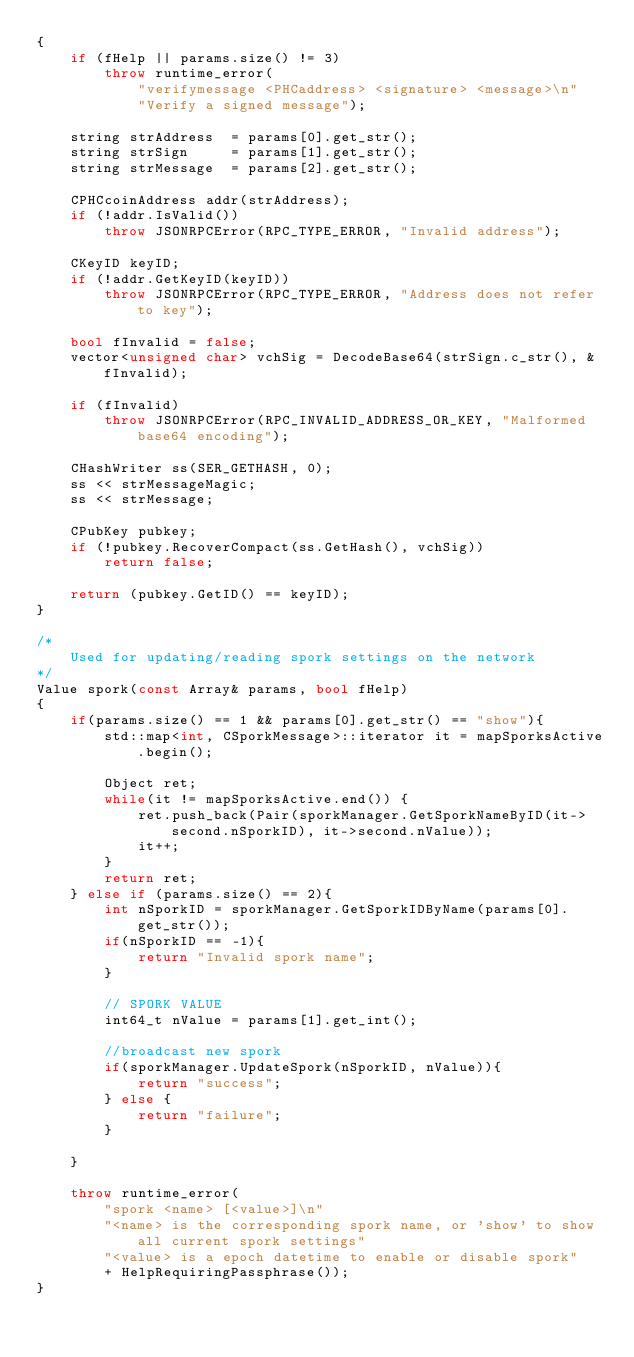<code> <loc_0><loc_0><loc_500><loc_500><_C++_>{
    if (fHelp || params.size() != 3)
        throw runtime_error(
            "verifymessage <PHCaddress> <signature> <message>\n"
            "Verify a signed message");

    string strAddress  = params[0].get_str();
    string strSign     = params[1].get_str();
    string strMessage  = params[2].get_str();

    CPHCcoinAddress addr(strAddress);
    if (!addr.IsValid())
        throw JSONRPCError(RPC_TYPE_ERROR, "Invalid address");

    CKeyID keyID;
    if (!addr.GetKeyID(keyID))
        throw JSONRPCError(RPC_TYPE_ERROR, "Address does not refer to key");

    bool fInvalid = false;
    vector<unsigned char> vchSig = DecodeBase64(strSign.c_str(), &fInvalid);

    if (fInvalid)
        throw JSONRPCError(RPC_INVALID_ADDRESS_OR_KEY, "Malformed base64 encoding");

    CHashWriter ss(SER_GETHASH, 0);
    ss << strMessageMagic;
    ss << strMessage;

    CPubKey pubkey;
    if (!pubkey.RecoverCompact(ss.GetHash(), vchSig))
        return false;

    return (pubkey.GetID() == keyID);
}

/*
    Used for updating/reading spork settings on the network
*/
Value spork(const Array& params, bool fHelp)
{
    if(params.size() == 1 && params[0].get_str() == "show"){
        std::map<int, CSporkMessage>::iterator it = mapSporksActive.begin();

        Object ret;
        while(it != mapSporksActive.end()) {
            ret.push_back(Pair(sporkManager.GetSporkNameByID(it->second.nSporkID), it->second.nValue));
            it++;
        }
        return ret;
    } else if (params.size() == 2){
        int nSporkID = sporkManager.GetSporkIDByName(params[0].get_str());
        if(nSporkID == -1){
            return "Invalid spork name";
        }

        // SPORK VALUE
        int64_t nValue = params[1].get_int();

        //broadcast new spork
        if(sporkManager.UpdateSpork(nSporkID, nValue)){
            return "success";
        } else {
            return "failure";
        }

    }

    throw runtime_error(
        "spork <name> [<value>]\n"
        "<name> is the corresponding spork name, or 'show' to show all current spork settings"
        "<value> is a epoch datetime to enable or disable spork"
        + HelpRequiringPassphrase());
}

</code> 